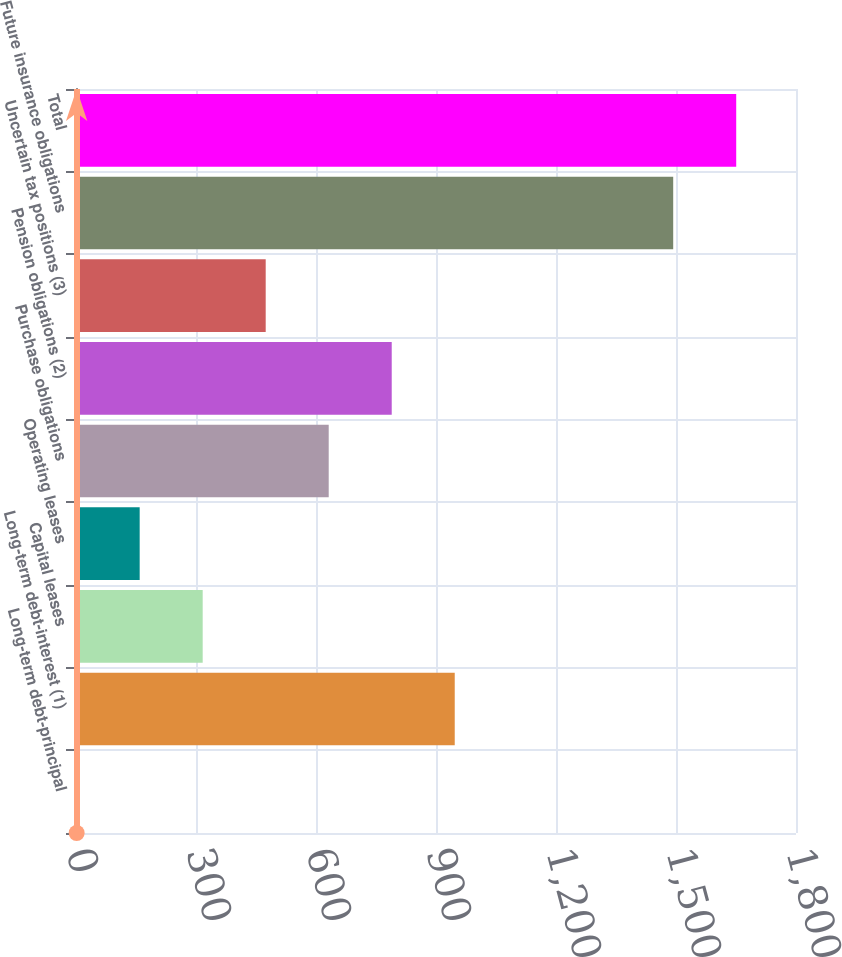Convert chart. <chart><loc_0><loc_0><loc_500><loc_500><bar_chart><fcel>Long-term debt-principal<fcel>Long-term debt-interest (1)<fcel>Capital leases<fcel>Operating leases<fcel>Purchase obligations<fcel>Pension obligations (2)<fcel>Uncertain tax positions (3)<fcel>Future insurance obligations<fcel>Total<nl><fcel>1.66<fcel>946.84<fcel>316.72<fcel>159.19<fcel>631.78<fcel>789.31<fcel>474.25<fcel>1493<fcel>1650.53<nl></chart> 